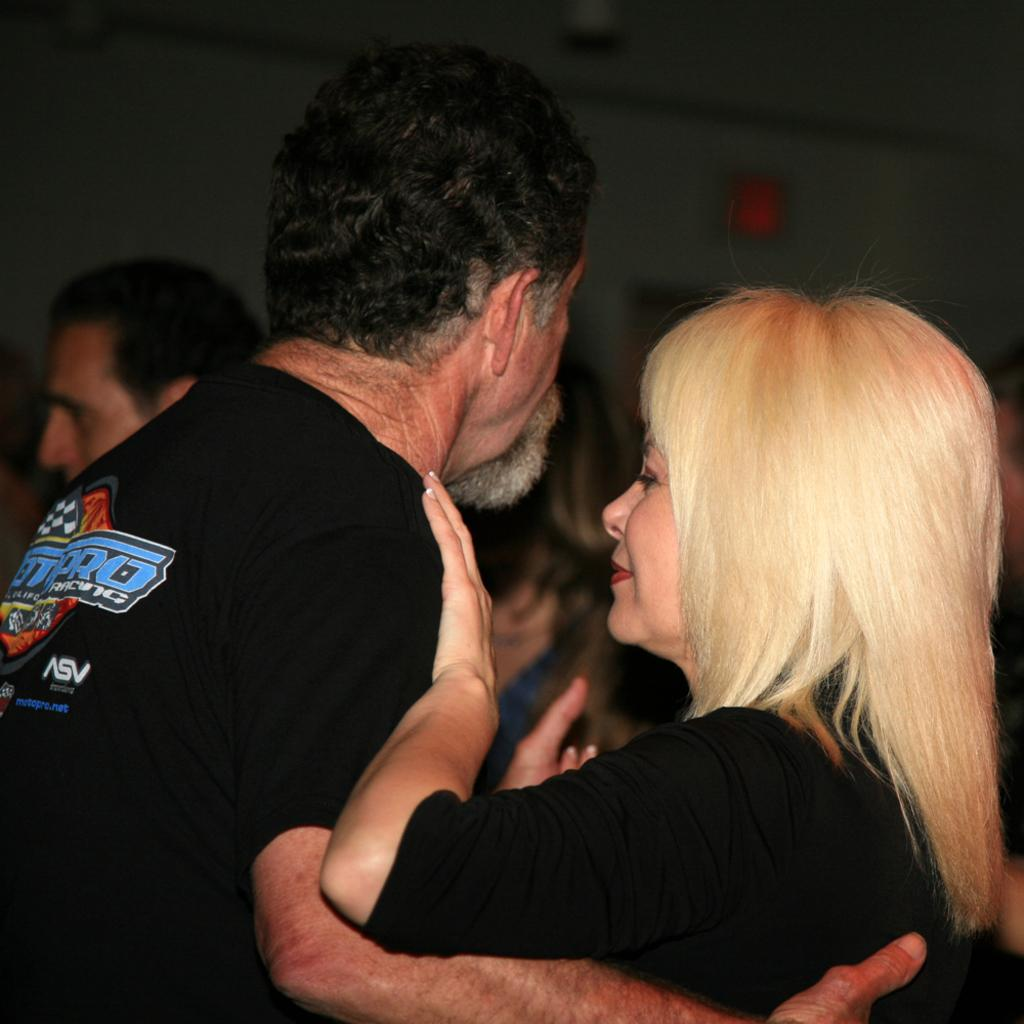<image>
Create a compact narrative representing the image presented. the man is wearing a tshirt with letters ASV on the right bottom corner 